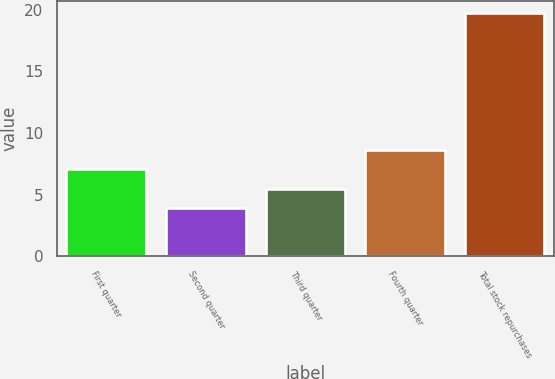Convert chart to OTSL. <chart><loc_0><loc_0><loc_500><loc_500><bar_chart><fcel>First quarter<fcel>Second quarter<fcel>Third quarter<fcel>Fourth quarter<fcel>Total stock repurchases<nl><fcel>7.06<fcel>3.9<fcel>5.48<fcel>8.64<fcel>19.7<nl></chart> 